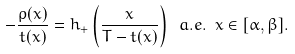Convert formula to latex. <formula><loc_0><loc_0><loc_500><loc_500>- \frac { \rho ( x ) } { t ( x ) } = h _ { + } \left ( \frac { x } { T - t ( x ) } \right ) \ a . e . \ x \in [ \alpha , \beta ] .</formula> 